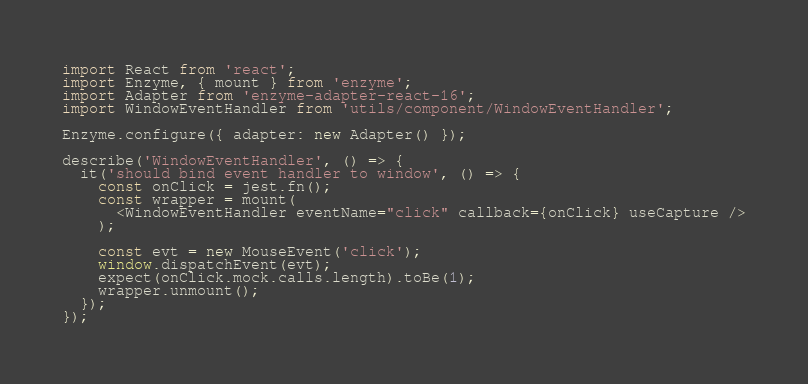<code> <loc_0><loc_0><loc_500><loc_500><_JavaScript_>import React from 'react';
import Enzyme, { mount } from 'enzyme';
import Adapter from 'enzyme-adapter-react-16';
import WindowEventHandler from 'utils/component/WindowEventHandler';

Enzyme.configure({ adapter: new Adapter() });

describe('WindowEventHandler', () => {
  it('should bind event handler to window', () => {
    const onClick = jest.fn();
    const wrapper = mount(
      <WindowEventHandler eventName="click" callback={onClick} useCapture />
    );

    const evt = new MouseEvent('click');
    window.dispatchEvent(evt);
    expect(onClick.mock.calls.length).toBe(1);
    wrapper.unmount();
  });
});
</code> 